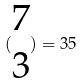Convert formula to latex. <formula><loc_0><loc_0><loc_500><loc_500>( \begin{matrix} 7 \\ 3 \end{matrix} ) = 3 5</formula> 